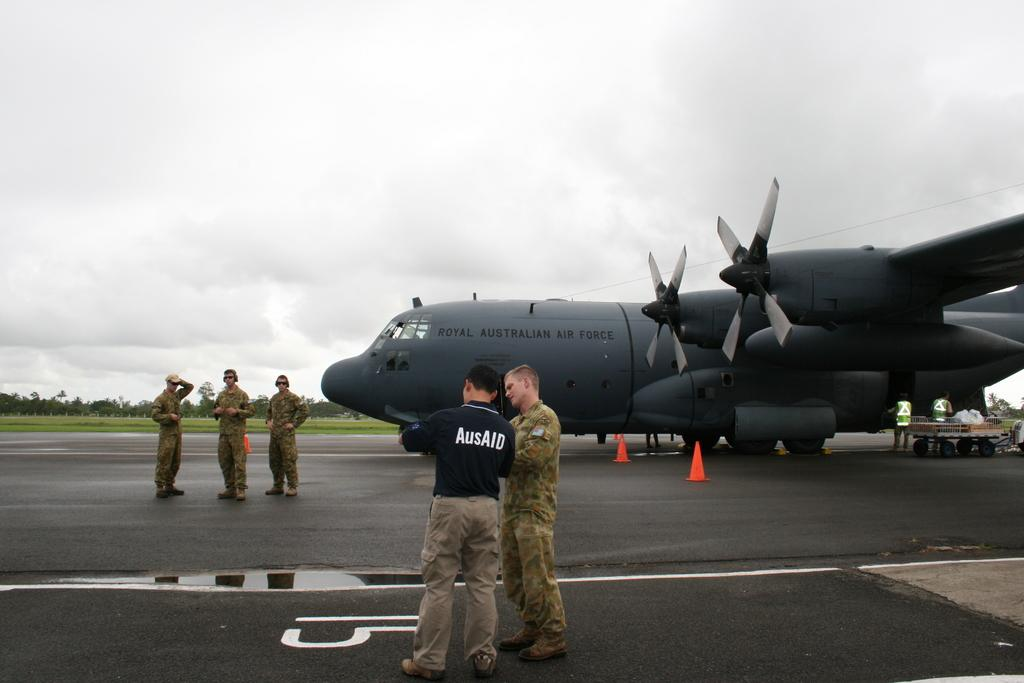Provide a one-sentence caption for the provided image. A few people standing next to a royal australian airplane. 